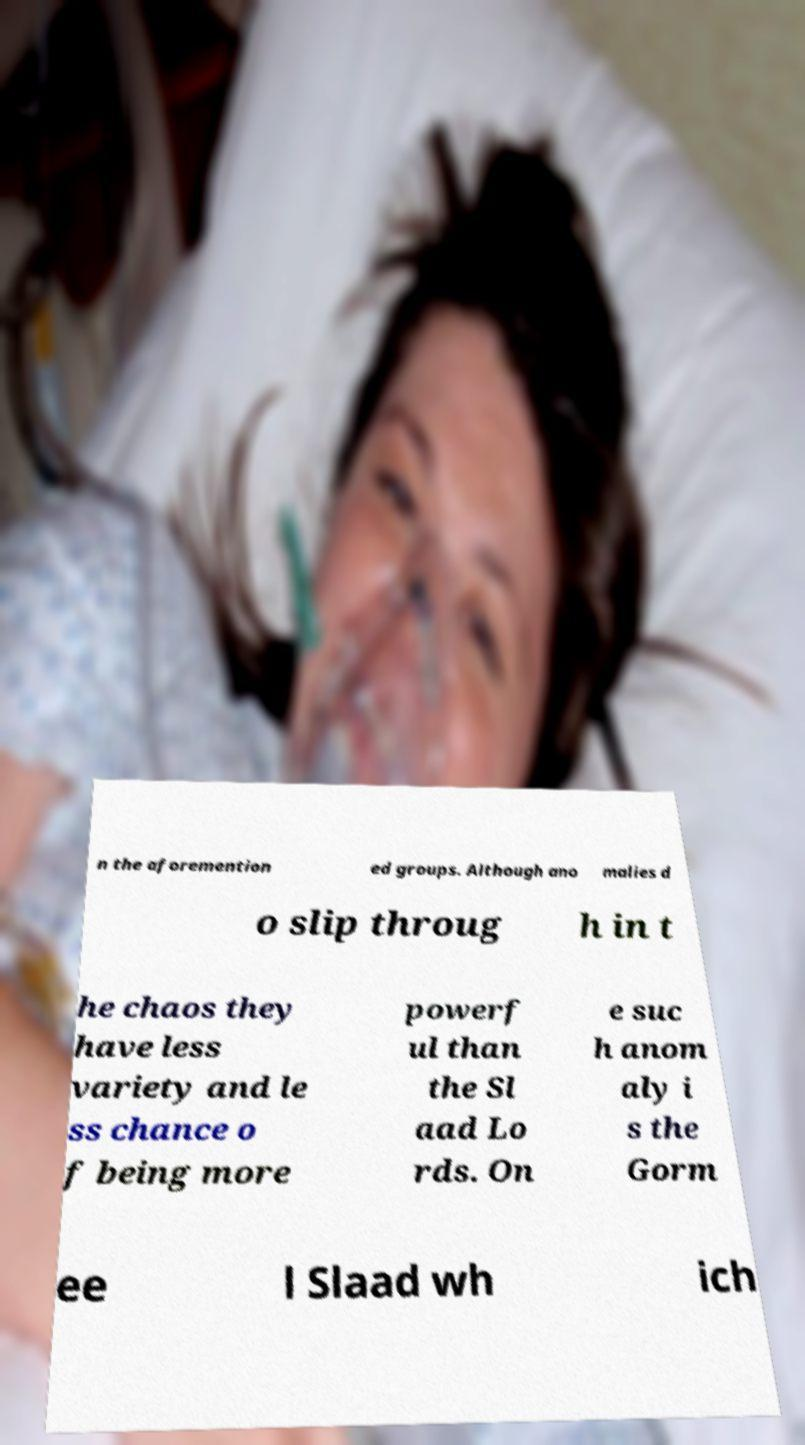Please read and relay the text visible in this image. What does it say? n the aforemention ed groups. Although ano malies d o slip throug h in t he chaos they have less variety and le ss chance o f being more powerf ul than the Sl aad Lo rds. On e suc h anom aly i s the Gorm ee l Slaad wh ich 